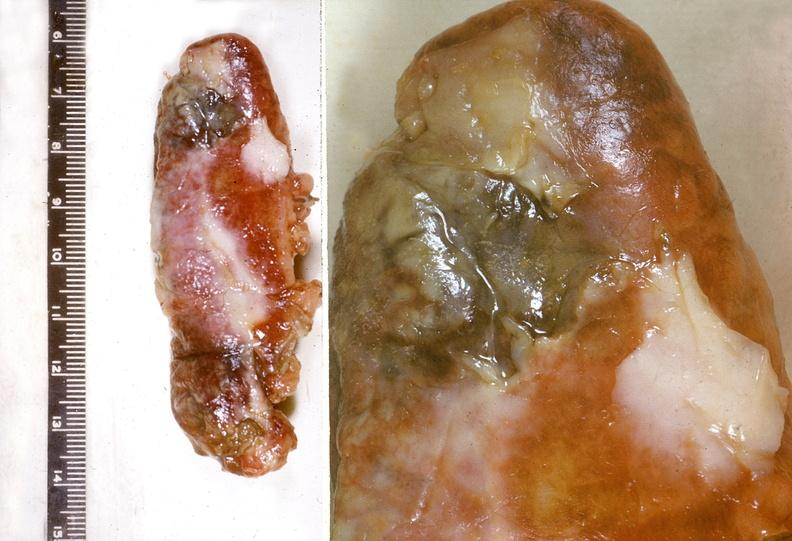s gastrointestinal present?
Answer the question using a single word or phrase. Yes 